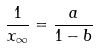Convert formula to latex. <formula><loc_0><loc_0><loc_500><loc_500>\frac { 1 } { x _ { \infty } } = \frac { a } { 1 - b }</formula> 